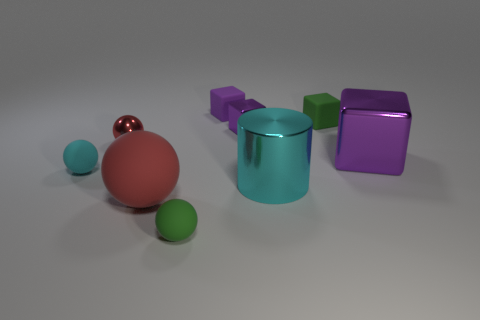Subtract all purple cubes. How many were subtracted if there are1purple cubes left? 2 Subtract all small cyan matte balls. How many balls are left? 3 Subtract all green spheres. How many spheres are left? 3 Subtract 1 blocks. How many blocks are left? 3 Subtract all yellow spheres. How many purple blocks are left? 3 Add 8 matte cubes. How many matte cubes exist? 10 Subtract 0 gray spheres. How many objects are left? 9 Subtract all cylinders. How many objects are left? 8 Subtract all red cubes. Subtract all cyan balls. How many cubes are left? 4 Subtract all purple metallic blocks. Subtract all large matte balls. How many objects are left? 6 